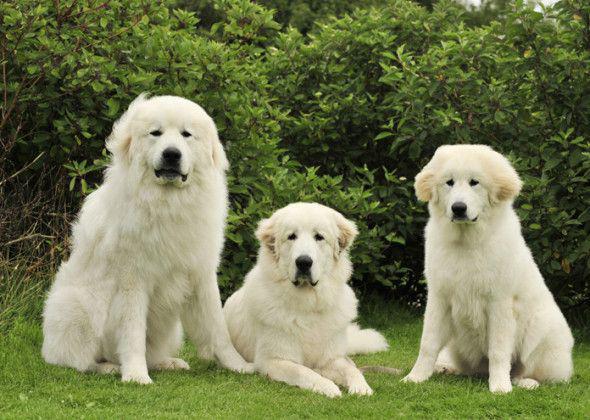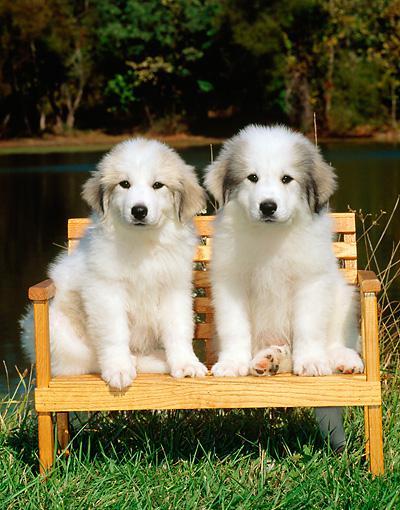The first image is the image on the left, the second image is the image on the right. Evaluate the accuracy of this statement regarding the images: "The combined images contain a total of four dogs, including a row of three dogs posed side-by-side.". Is it true? Answer yes or no. No. The first image is the image on the left, the second image is the image on the right. Analyze the images presented: Is the assertion "There are exactly four dogs." valid? Answer yes or no. No. 